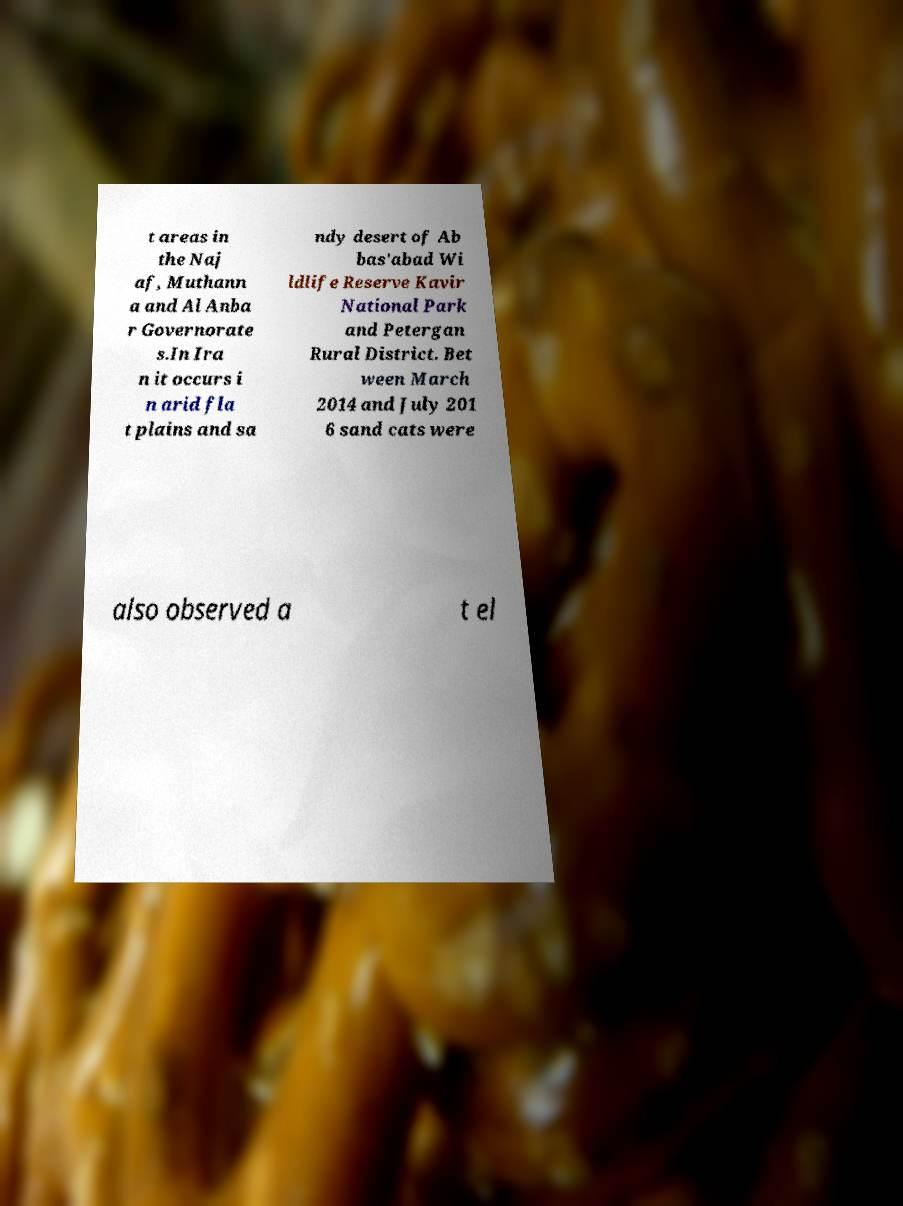Please read and relay the text visible in this image. What does it say? t areas in the Naj af, Muthann a and Al Anba r Governorate s.In Ira n it occurs i n arid fla t plains and sa ndy desert of Ab bas'abad Wi ldlife Reserve Kavir National Park and Petergan Rural District. Bet ween March 2014 and July 201 6 sand cats were also observed a t el 